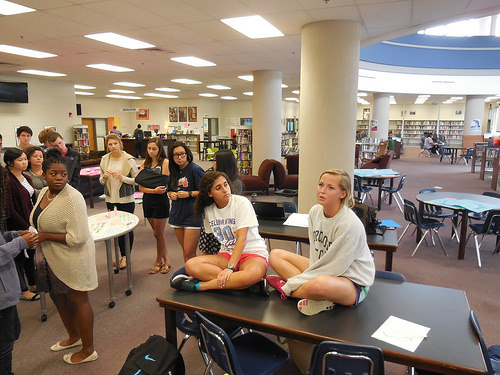<image>
Is there a girl to the right of the table? No. The girl is not to the right of the table. The horizontal positioning shows a different relationship. Where is the girl in relation to the pole? Is it in front of the pole? Yes. The girl is positioned in front of the pole, appearing closer to the camera viewpoint. 